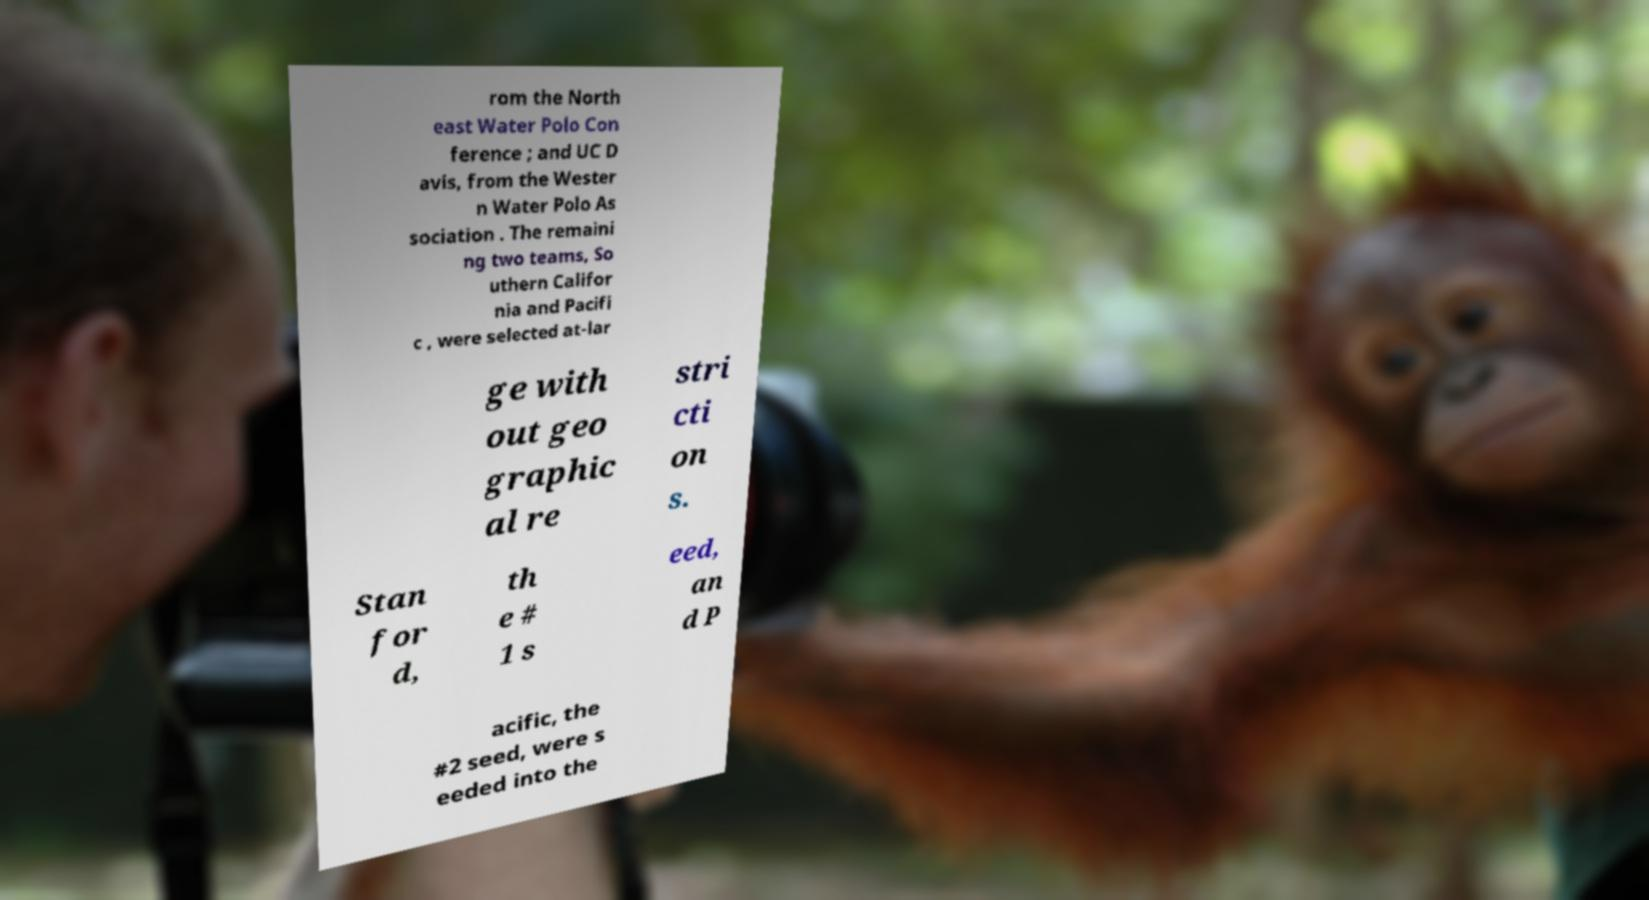What messages or text are displayed in this image? I need them in a readable, typed format. rom the North east Water Polo Con ference ; and UC D avis, from the Wester n Water Polo As sociation . The remaini ng two teams, So uthern Califor nia and Pacifi c , were selected at-lar ge with out geo graphic al re stri cti on s. Stan for d, th e # 1 s eed, an d P acific, the #2 seed, were s eeded into the 